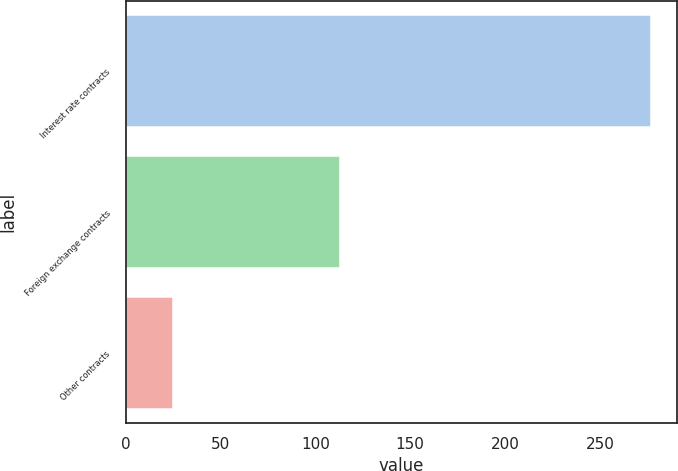<chart> <loc_0><loc_0><loc_500><loc_500><bar_chart><fcel>Interest rate contracts<fcel>Foreign exchange contracts<fcel>Other contracts<nl><fcel>277<fcel>113<fcel>25<nl></chart> 